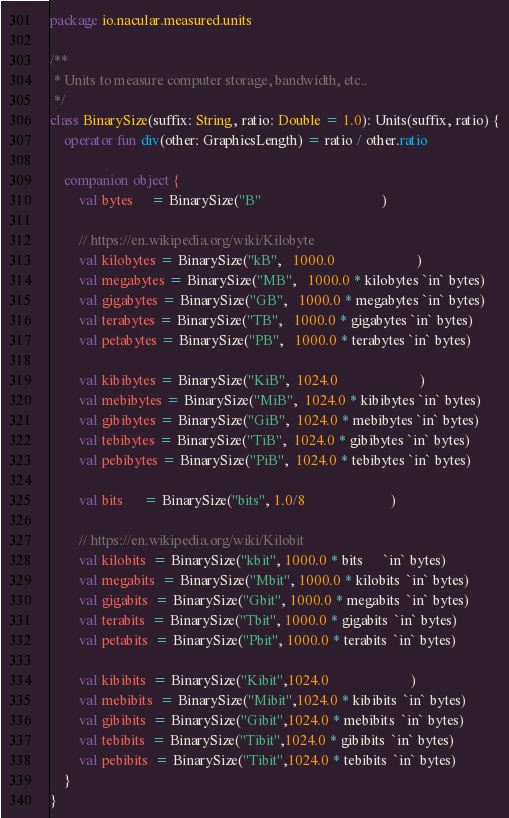Convert code to text. <code><loc_0><loc_0><loc_500><loc_500><_Kotlin_>package io.nacular.measured.units

/**
 * Units to measure computer storage, bandwidth, etc..
 */
class BinarySize(suffix: String, ratio: Double = 1.0): Units(suffix, ratio) {
    operator fun div(other: GraphicsLength) = ratio / other.ratio

    companion object {
        val bytes     = BinarySize("B"                                  )

        // https://en.wikipedia.org/wiki/Kilobyte
        val kilobytes = BinarySize("kB",   1000.0                       )
        val megabytes = BinarySize("MB",   1000.0 * kilobytes `in` bytes)
        val gigabytes = BinarySize("GB",   1000.0 * megabytes `in` bytes)
        val terabytes = BinarySize("TB",   1000.0 * gigabytes `in` bytes)
        val petabytes = BinarySize("PB",   1000.0 * terabytes `in` bytes)

        val kibibytes = BinarySize("KiB",  1024.0                       )
        val mebibytes = BinarySize("MiB",  1024.0 * kibibytes `in` bytes)
        val gibibytes = BinarySize("GiB",  1024.0 * mebibytes `in` bytes)
        val tebibytes = BinarySize("TiB",  1024.0 * gibibytes `in` bytes)
        val pebibytes = BinarySize("PiB",  1024.0 * tebibytes `in` bytes)

        val bits      = BinarySize("bits", 1.0/8                        )

        // https://en.wikipedia.org/wiki/Kilobit
        val kilobits  = BinarySize("kbit", 1000.0 * bits      `in` bytes)
        val megabits  = BinarySize("Mbit", 1000.0 * kilobits  `in` bytes)
        val gigabits  = BinarySize("Gbit", 1000.0 * megabits  `in` bytes)
        val terabits  = BinarySize("Tbit", 1000.0 * gigabits  `in` bytes)
        val petabits  = BinarySize("Pbit", 1000.0 * terabits  `in` bytes)

        val kibibits  = BinarySize("Kibit",1024.0                       )
        val mebibits  = BinarySize("Mibit",1024.0 * kibibits  `in` bytes)
        val gibibits  = BinarySize("Gibit",1024.0 * mebibits  `in` bytes)
        val tebibits  = BinarySize("Tibit",1024.0 * gibibits  `in` bytes)
        val pebibits  = BinarySize("Tibit",1024.0 * tebibits  `in` bytes)
    }
}</code> 